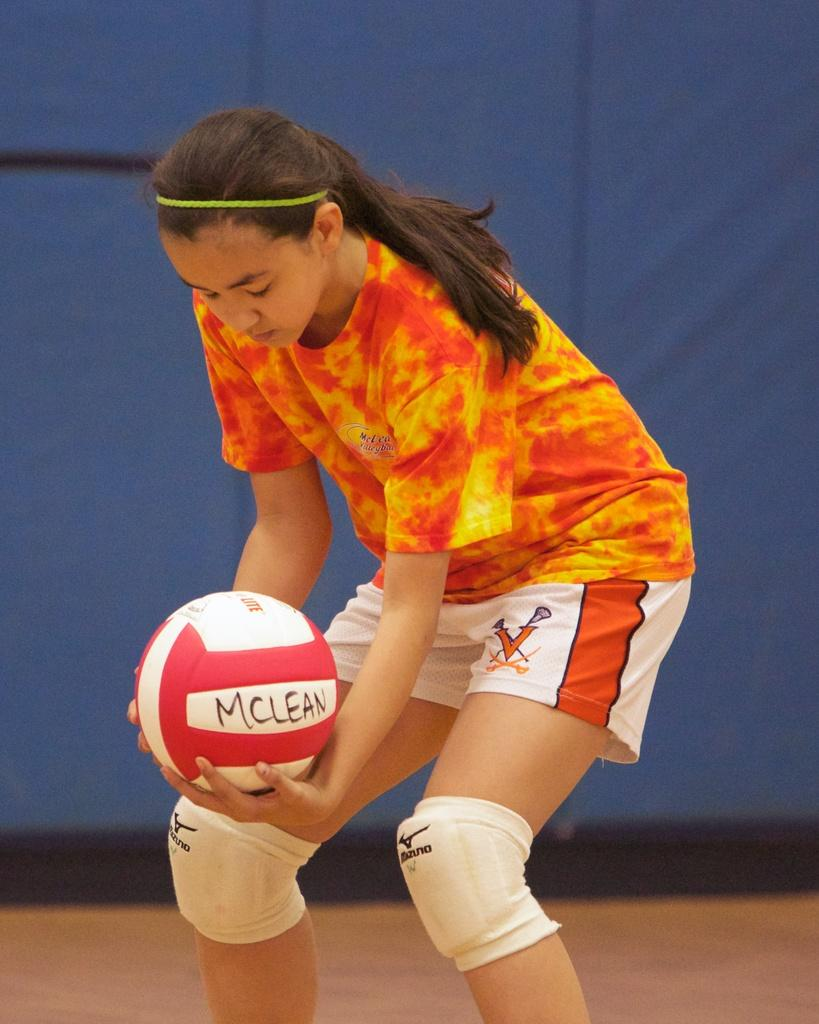What is the main subject of the picture? The main subject of the picture is a standing woman. What is the woman holding in her hands? The woman is holding a ball in her hands. What type of temper does the woman have in the image? There is no information about the woman's temper in the image. Is the woman a spy in the image? There is no indication that the woman is a spy in the image. What type of cabbage is present in the image? There is no cabbage present in the image. 